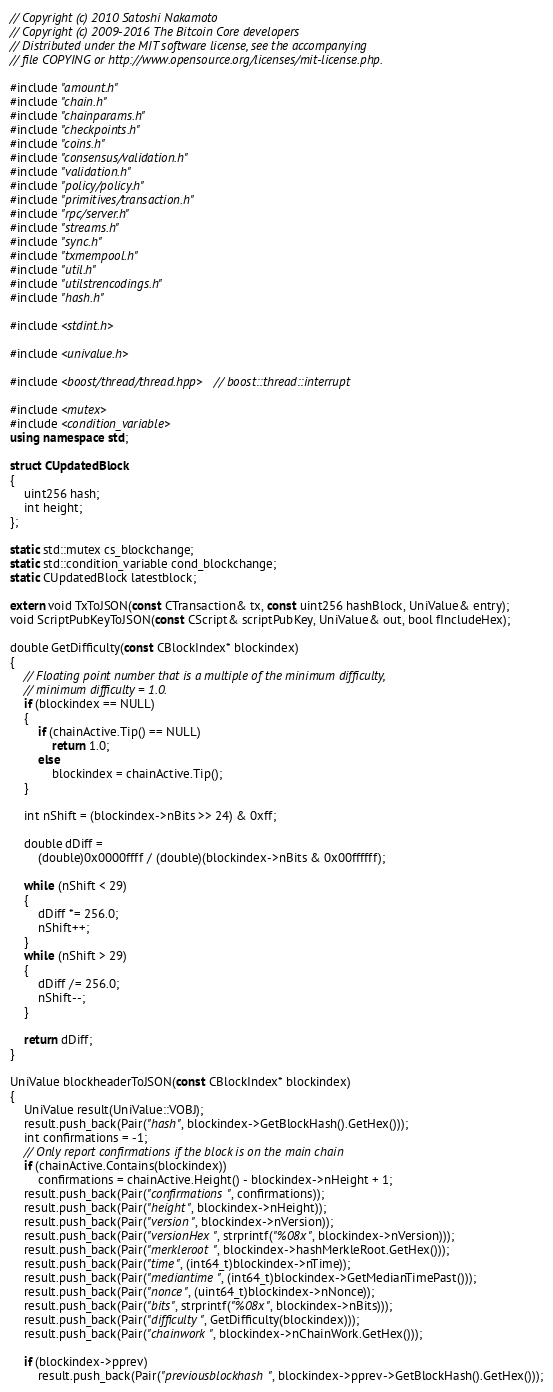Convert code to text. <code><loc_0><loc_0><loc_500><loc_500><_C++_>// Copyright (c) 2010 Satoshi Nakamoto
// Copyright (c) 2009-2016 The Bitcoin Core developers
// Distributed under the MIT software license, see the accompanying
// file COPYING or http://www.opensource.org/licenses/mit-license.php.

#include "amount.h"
#include "chain.h"
#include "chainparams.h"
#include "checkpoints.h"
#include "coins.h"
#include "consensus/validation.h"
#include "validation.h"
#include "policy/policy.h"
#include "primitives/transaction.h"
#include "rpc/server.h"
#include "streams.h"
#include "sync.h"
#include "txmempool.h"
#include "util.h"
#include "utilstrencodings.h"
#include "hash.h"

#include <stdint.h>

#include <univalue.h>

#include <boost/thread/thread.hpp> // boost::thread::interrupt

#include <mutex>
#include <condition_variable>
using namespace std;

struct CUpdatedBlock
{
    uint256 hash;
    int height;
};

static std::mutex cs_blockchange;
static std::condition_variable cond_blockchange;
static CUpdatedBlock latestblock;

extern void TxToJSON(const CTransaction& tx, const uint256 hashBlock, UniValue& entry);
void ScriptPubKeyToJSON(const CScript& scriptPubKey, UniValue& out, bool fIncludeHex);

double GetDifficulty(const CBlockIndex* blockindex)
{
    // Floating point number that is a multiple of the minimum difficulty,
    // minimum difficulty = 1.0.
    if (blockindex == NULL)
    {
        if (chainActive.Tip() == NULL)
            return 1.0;
        else
            blockindex = chainActive.Tip();
    }

    int nShift = (blockindex->nBits >> 24) & 0xff;

    double dDiff =
        (double)0x0000ffff / (double)(blockindex->nBits & 0x00ffffff);

    while (nShift < 29)
    {
        dDiff *= 256.0;
        nShift++;
    }
    while (nShift > 29)
    {
        dDiff /= 256.0;
        nShift--;
    }

    return dDiff;
}

UniValue blockheaderToJSON(const CBlockIndex* blockindex)
{
    UniValue result(UniValue::VOBJ);
    result.push_back(Pair("hash", blockindex->GetBlockHash().GetHex()));
    int confirmations = -1;
    // Only report confirmations if the block is on the main chain
    if (chainActive.Contains(blockindex))
        confirmations = chainActive.Height() - blockindex->nHeight + 1;
    result.push_back(Pair("confirmations", confirmations));
    result.push_back(Pair("height", blockindex->nHeight));
    result.push_back(Pair("version", blockindex->nVersion));
    result.push_back(Pair("versionHex", strprintf("%08x", blockindex->nVersion)));
    result.push_back(Pair("merkleroot", blockindex->hashMerkleRoot.GetHex()));
    result.push_back(Pair("time", (int64_t)blockindex->nTime));
    result.push_back(Pair("mediantime", (int64_t)blockindex->GetMedianTimePast()));
    result.push_back(Pair("nonce", (uint64_t)blockindex->nNonce));
    result.push_back(Pair("bits", strprintf("%08x", blockindex->nBits)));
    result.push_back(Pair("difficulty", GetDifficulty(blockindex)));
    result.push_back(Pair("chainwork", blockindex->nChainWork.GetHex()));

    if (blockindex->pprev)
        result.push_back(Pair("previousblockhash", blockindex->pprev->GetBlockHash().GetHex()));</code> 